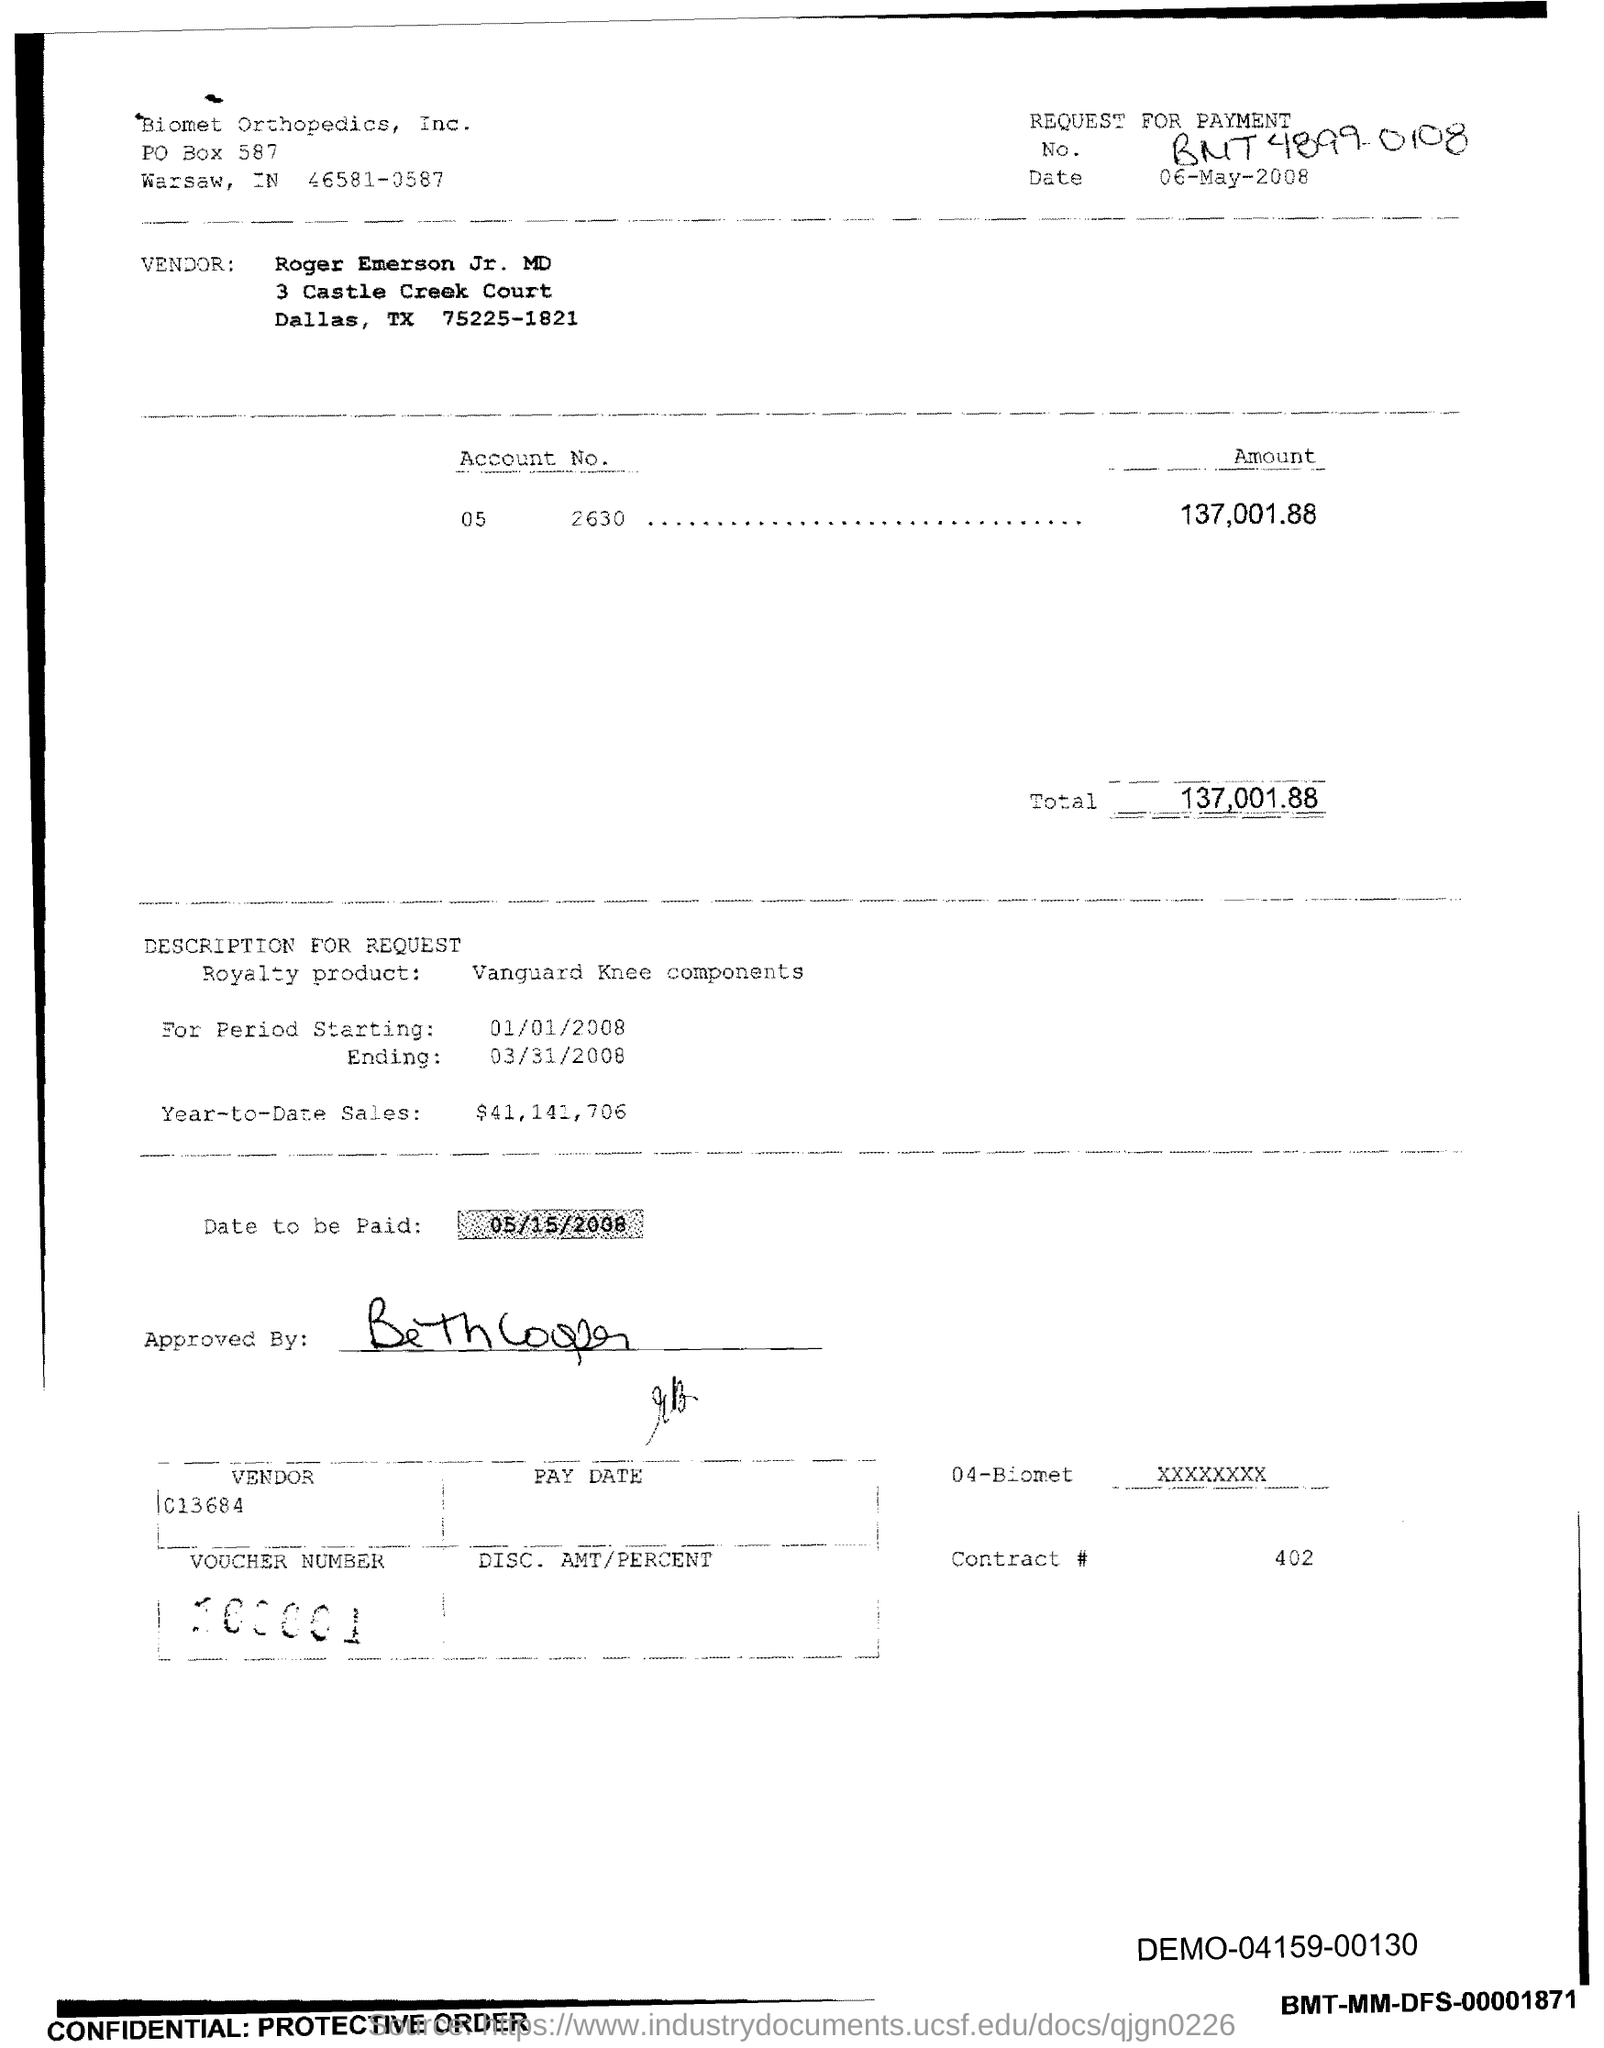List a handful of essential elements in this visual. The total is 137,001, with an additional amount of 88. The PO Box number mentioned in the document is 587. 